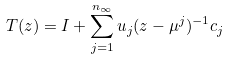<formula> <loc_0><loc_0><loc_500><loc_500>T ( z ) = I + \sum _ { j = 1 } ^ { n _ { \infty } } u _ { j } ( z - \mu ^ { j } ) ^ { - 1 } c _ { j }</formula> 